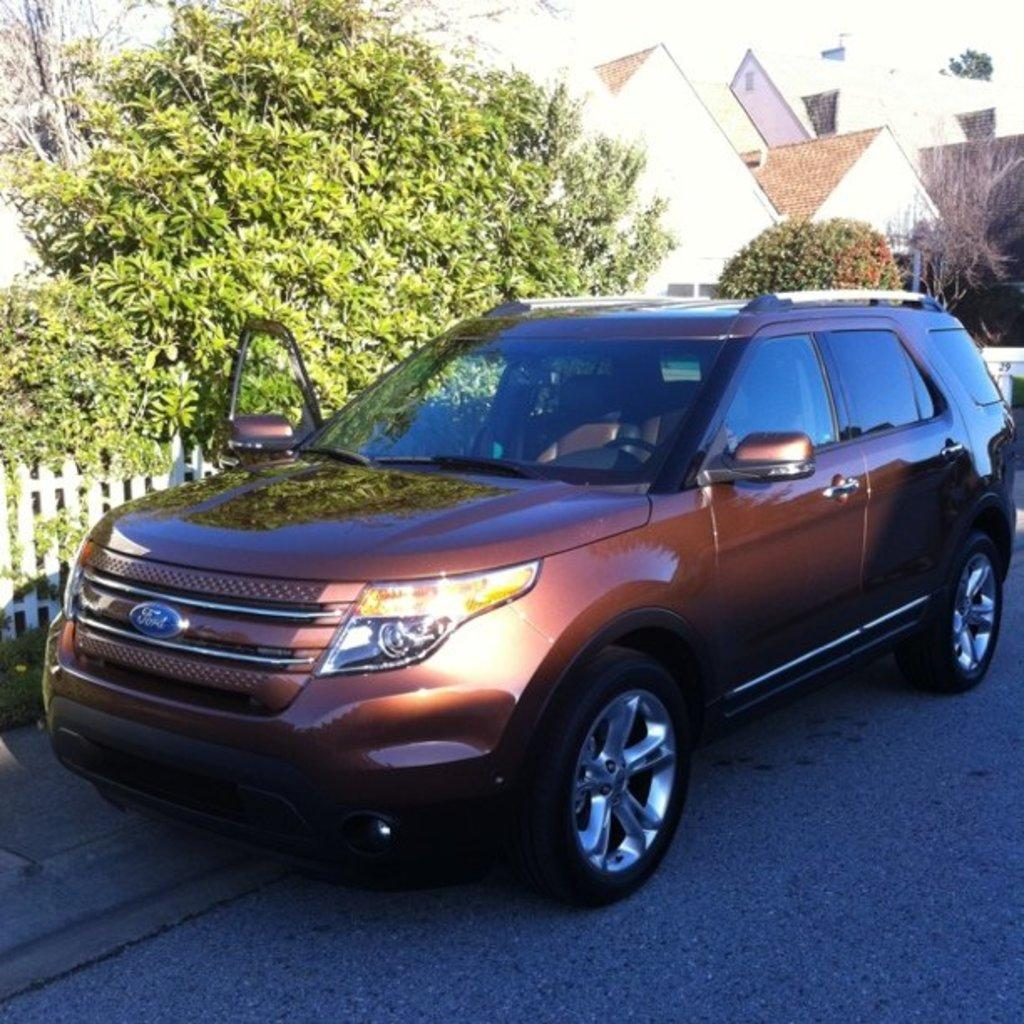What is the main subject of the image? The main subject of the image is a car on the road. What can be seen in the background of the image? There are trees and buildings visible in the image. What type of barrier is present in the image? There is a fence in the image. What color is the lipstick worn by the car in the image? There is no lipstick or car wearing lipstick present in the image. What type of station is visible in the image? There is no station present in the image. 